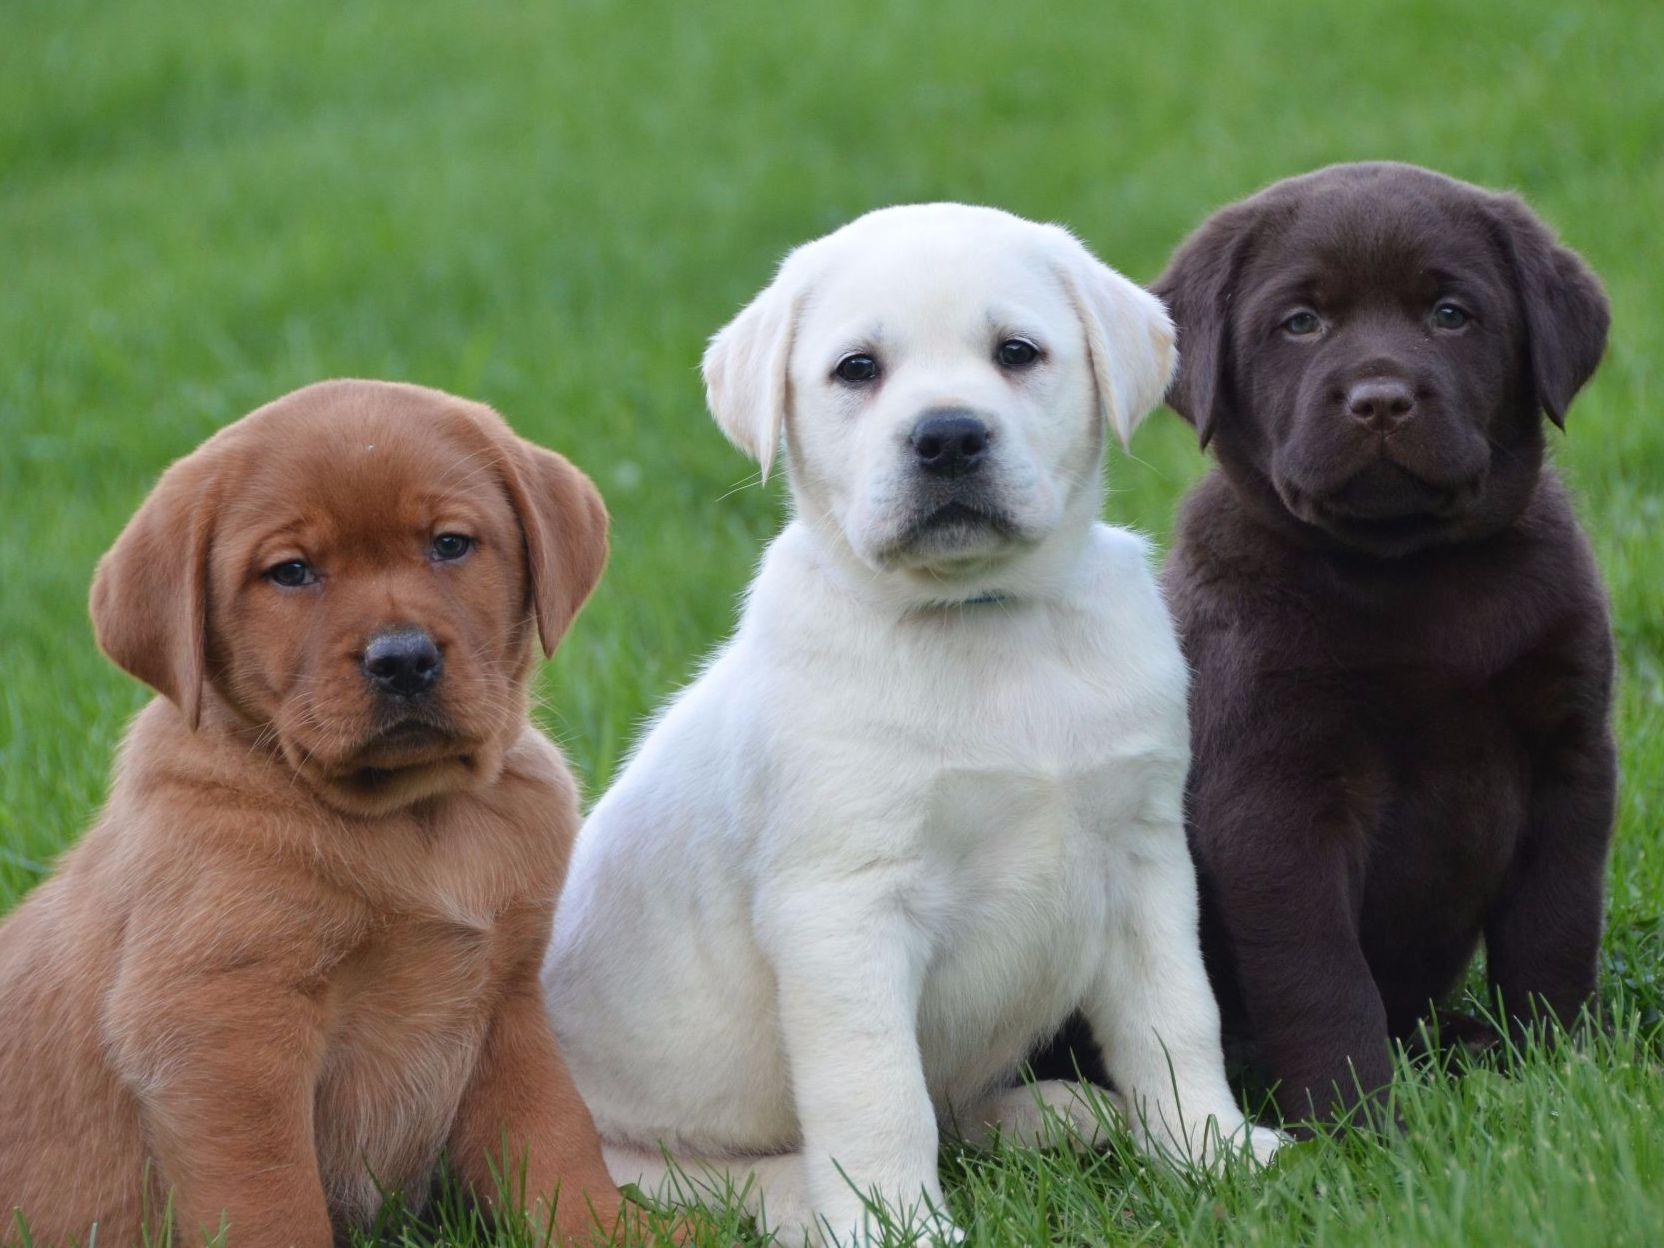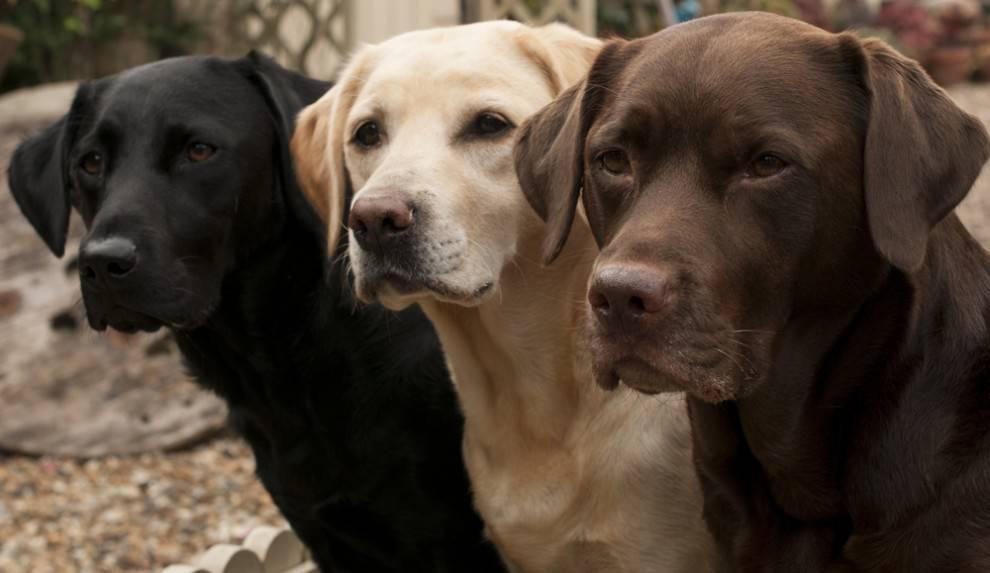The first image is the image on the left, the second image is the image on the right. Examine the images to the left and right. Is the description "There are five puppies in the image pair." accurate? Answer yes or no. No. The first image is the image on the left, the second image is the image on the right. For the images displayed, is the sentence "There are no more than two dogs in the right image." factually correct? Answer yes or no. No. 